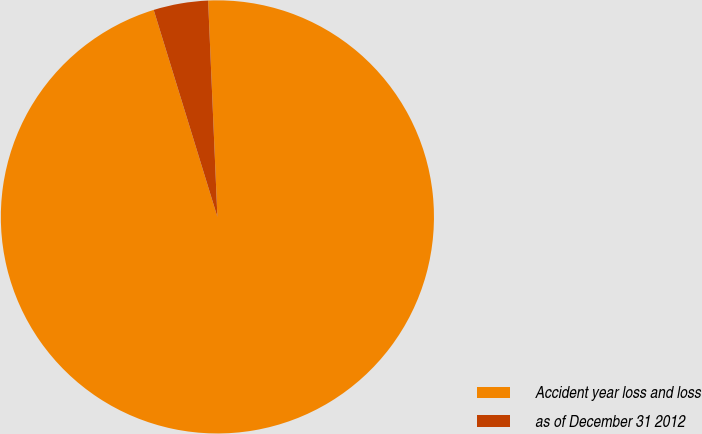Convert chart. <chart><loc_0><loc_0><loc_500><loc_500><pie_chart><fcel>Accident year loss and loss<fcel>as of December 31 2012<nl><fcel>95.93%<fcel>4.07%<nl></chart> 